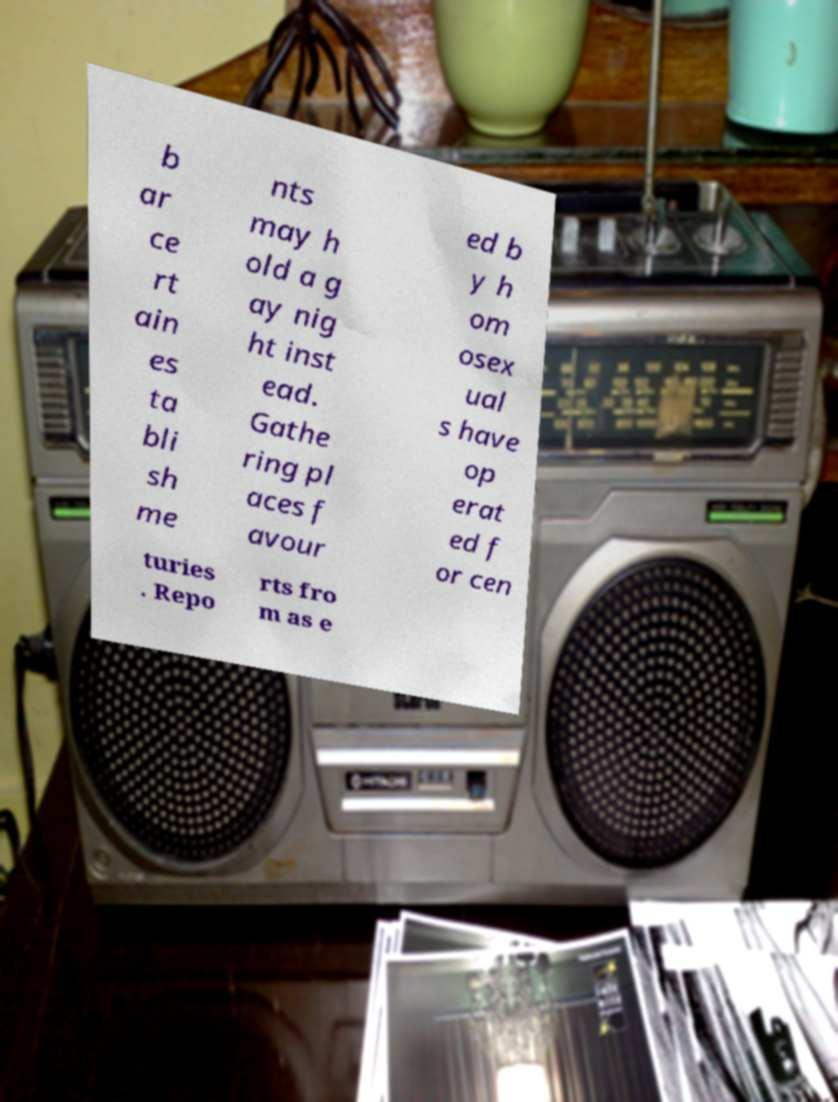For documentation purposes, I need the text within this image transcribed. Could you provide that? b ar ce rt ain es ta bli sh me nts may h old a g ay nig ht inst ead. Gathe ring pl aces f avour ed b y h om osex ual s have op erat ed f or cen turies . Repo rts fro m as e 